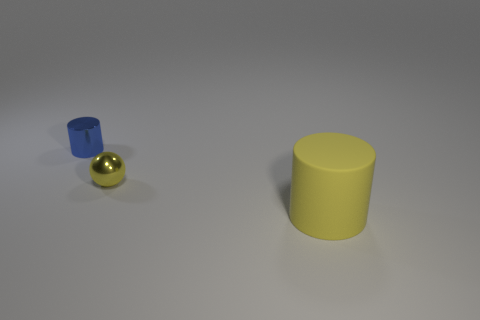Can you describe the shapes in the image in terms of their geometry? Certainly, the image displays three geometric shapes. On the left, there's a blue cylinder standing upright. In the middle, there's a small golden sphere with reflective properties. And to the right, we see a larger cylinder also standing upright, but this one has a yellow matte finish. 